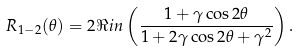Convert formula to latex. <formula><loc_0><loc_0><loc_500><loc_500>R _ { 1 - 2 } ( \theta ) = 2 \Re i n \left ( \frac { 1 + \gamma \cos 2 \theta } { 1 + 2 \gamma \cos 2 \theta + \gamma ^ { 2 } } \right ) .</formula> 